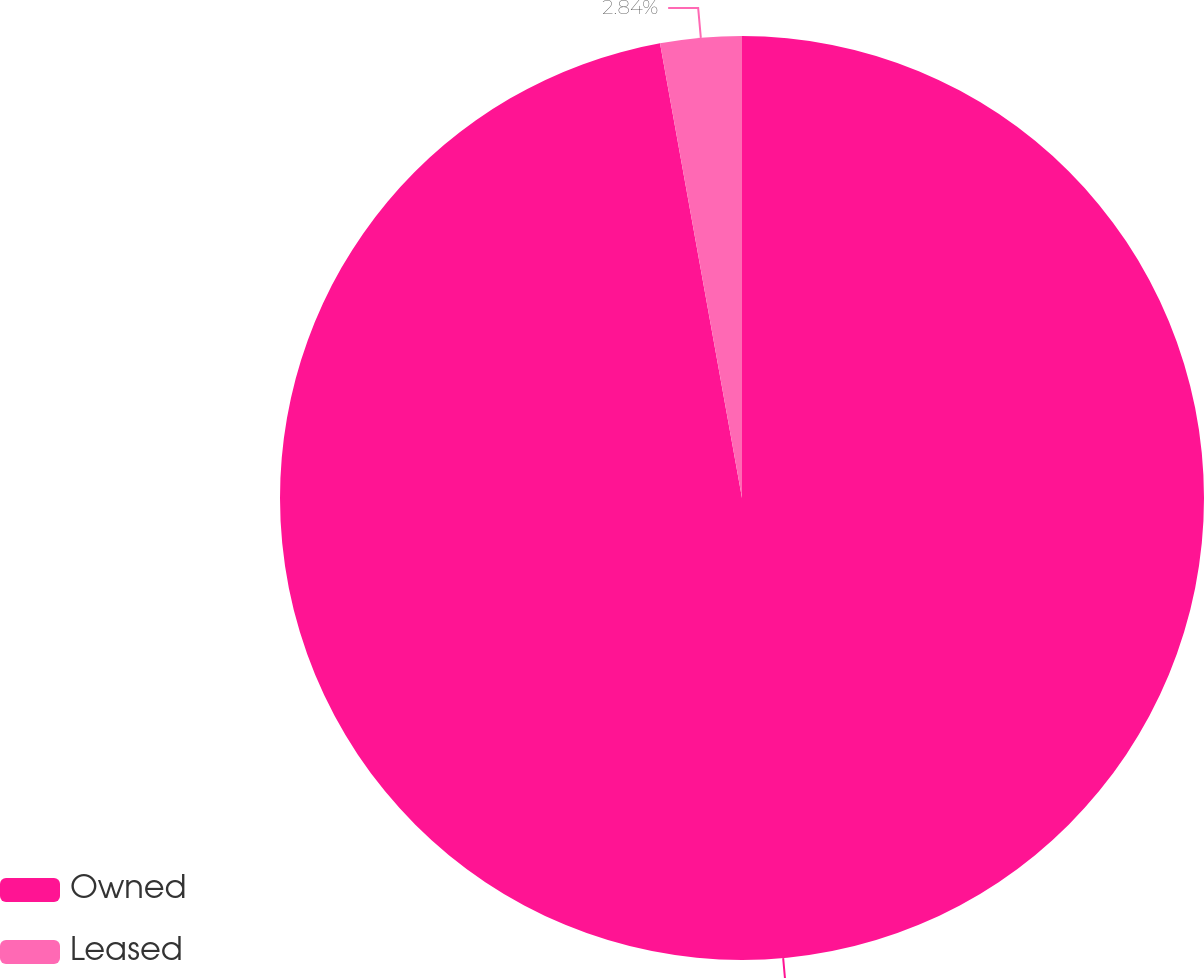<chart> <loc_0><loc_0><loc_500><loc_500><pie_chart><fcel>Owned<fcel>Leased<nl><fcel>97.16%<fcel>2.84%<nl></chart> 